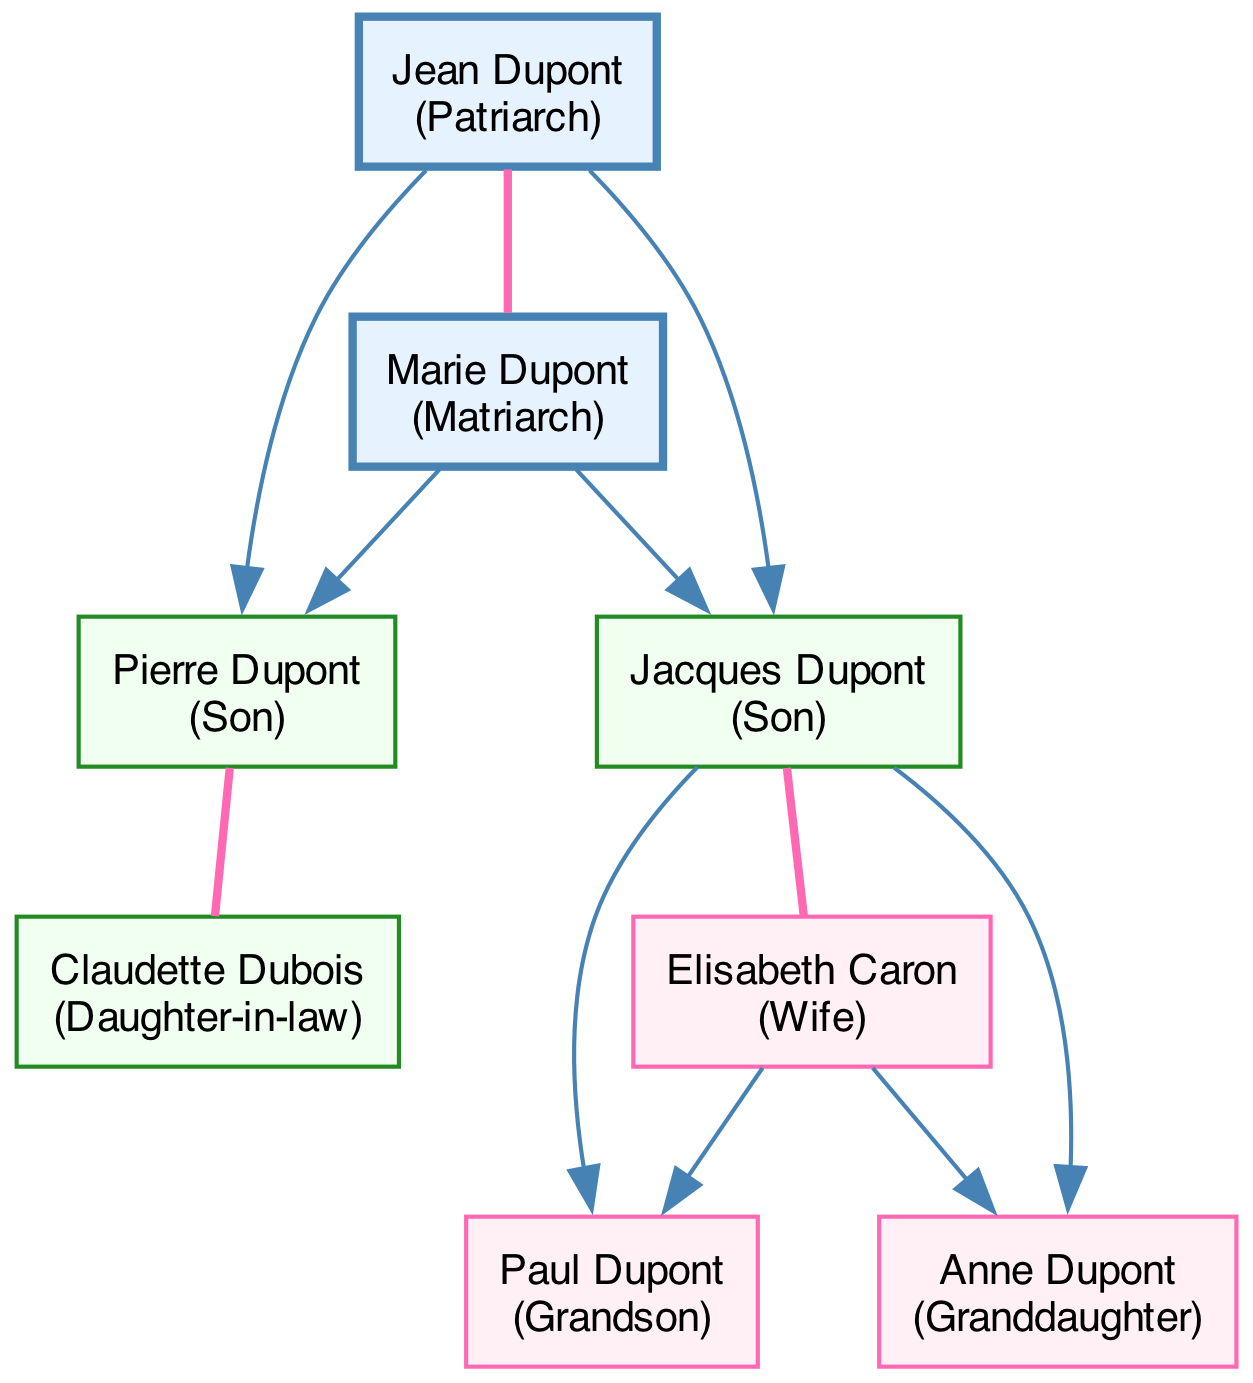What is the name of the Patriarch? The diagram identifies Jean Dupont as the Patriarch by showing his role clearly labeled within a rectangular node.
Answer: Jean Dupont How many sons are represented in the diagram? Analyzing the nodes, we see two individuals designated as sons: Pierre Dupont and Jacques Dupont. This leads to the conclusion that there are two sons total.
Answer: 2 Who is the spouse of Jacques Dupont? By examining the edges, we can see that a line connects Jacques Dupont to Elisabeth Caron with the relationship label of "Spouse." Thus, Elisabeth Caron is identified as his spouse.
Answer: Elisabeth Caron What is the relationship between Jean Dupont and Marie Dupont? The diagram shows an edge connecting Jean Dupont and Marie Dupont with the relationship labeled as "Spouse," indicating they are married to each other.
Answer: Spouse How many grandchildren does Pierre Dupont have? Looking at the nodes representing the children of Pierre Dupont, we find two grandchildren listed: Paul Dupont and Anne Dupont, thus confirming that he has two grandchildren.
Answer: 2 Which role is associated with Claudette Dubois? The role assigned to Claudette Dubois is specified within her node, clearly marked as "Daughter-in-law," showing her familial position in the tree.
Answer: Daughter-in-law Which generation does Paul Dupont belong to? By tracing the family tree from the patriarch and matriarch down to the descendants, we identify Paul Dupont as a grandson, placing him in the generation following his parents.
Answer: Grandson Who are the parents of Anne Dupont? To determine the parents of Anne Dupont, we refer to the edges and find she is connected to Jacques Dupont and Elisabeth Caron, which tells us they are her parents.
Answer: Jacques Dupont and Elisabeth Caron What is the total number of nodes in the diagram? Counting all individual family members represented in the nodes, we find there are a total of eight nodes in the diagram.
Answer: 8 What color represents the Matriarch in the diagram? The node representing the Matriarch is colored with a light blue fill, as denoted in the diagram's design choices for matriarchal figures.
Answer: Light blue 